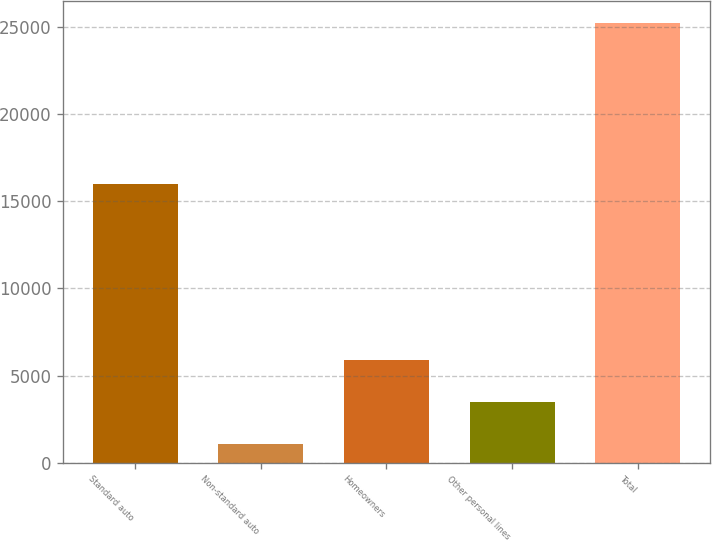Convert chart. <chart><loc_0><loc_0><loc_500><loc_500><bar_chart><fcel>Standard auto<fcel>Non-standard auto<fcel>Homeowners<fcel>Other personal lines<fcel>Total<nl><fcel>15957<fcel>1055<fcel>5884.8<fcel>3469.9<fcel>25204<nl></chart> 